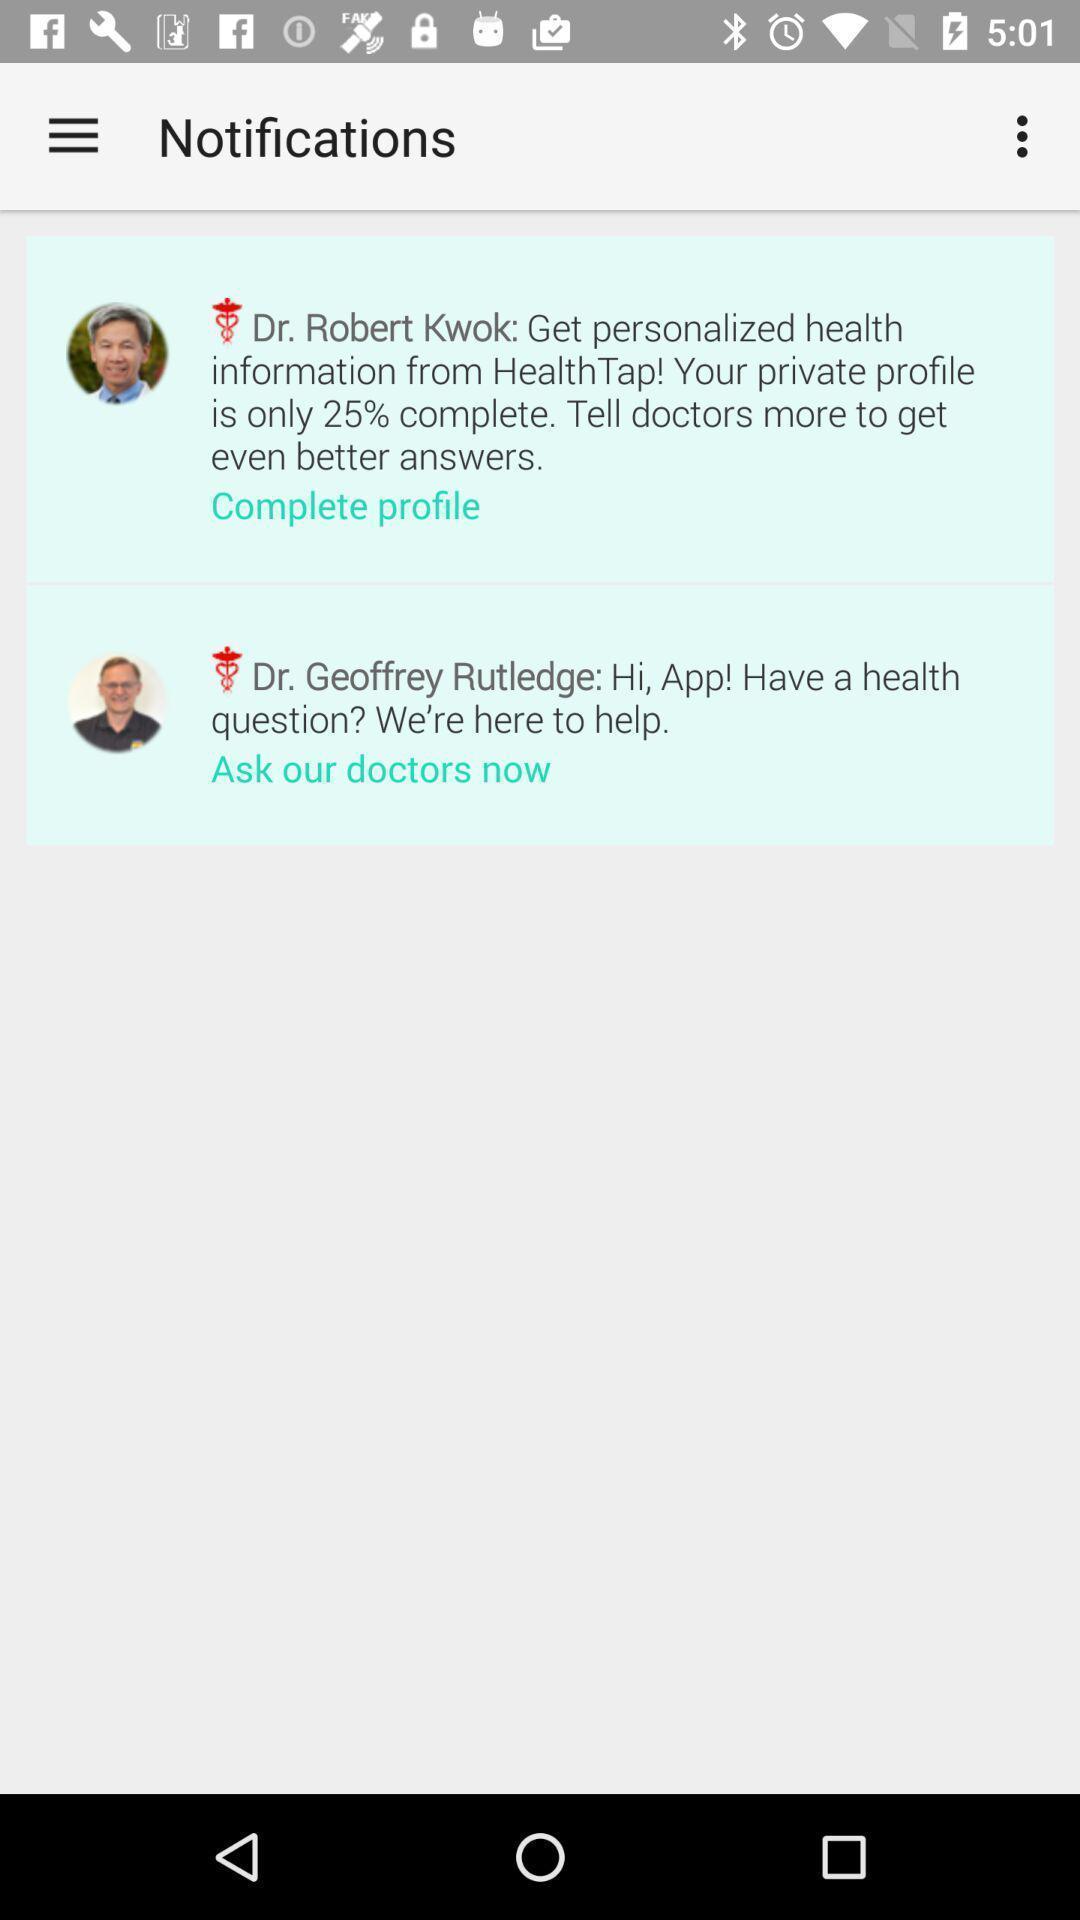Tell me what you see in this picture. Screen displaying settings. 